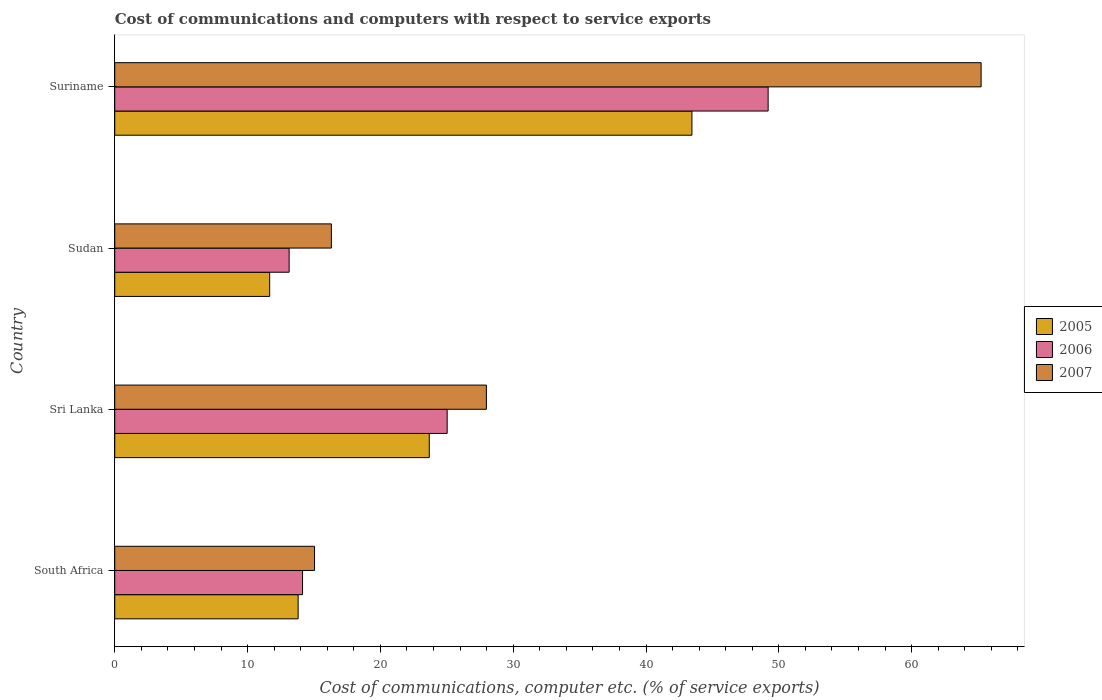How many different coloured bars are there?
Keep it short and to the point. 3. How many groups of bars are there?
Ensure brevity in your answer.  4. Are the number of bars on each tick of the Y-axis equal?
Your response must be concise. Yes. What is the label of the 4th group of bars from the top?
Provide a short and direct response. South Africa. What is the cost of communications and computers in 2006 in Suriname?
Provide a short and direct response. 49.2. Across all countries, what is the maximum cost of communications and computers in 2006?
Ensure brevity in your answer.  49.2. Across all countries, what is the minimum cost of communications and computers in 2007?
Make the answer very short. 15.04. In which country was the cost of communications and computers in 2005 maximum?
Your answer should be compact. Suriname. In which country was the cost of communications and computers in 2006 minimum?
Offer a terse response. Sudan. What is the total cost of communications and computers in 2007 in the graph?
Offer a very short reply. 124.57. What is the difference between the cost of communications and computers in 2005 in South Africa and that in Suriname?
Your answer should be very brief. -29.65. What is the difference between the cost of communications and computers in 2006 in Sudan and the cost of communications and computers in 2007 in South Africa?
Ensure brevity in your answer.  -1.91. What is the average cost of communications and computers in 2006 per country?
Make the answer very short. 25.37. What is the difference between the cost of communications and computers in 2006 and cost of communications and computers in 2005 in South Africa?
Provide a succinct answer. 0.33. What is the ratio of the cost of communications and computers in 2007 in South Africa to that in Suriname?
Offer a very short reply. 0.23. What is the difference between the highest and the second highest cost of communications and computers in 2005?
Provide a short and direct response. 19.78. What is the difference between the highest and the lowest cost of communications and computers in 2006?
Make the answer very short. 36.07. In how many countries, is the cost of communications and computers in 2006 greater than the average cost of communications and computers in 2006 taken over all countries?
Offer a terse response. 1. Is the sum of the cost of communications and computers in 2007 in South Africa and Sri Lanka greater than the maximum cost of communications and computers in 2005 across all countries?
Your answer should be very brief. No. What does the 3rd bar from the top in Sudan represents?
Keep it short and to the point. 2005. What does the 2nd bar from the bottom in Sri Lanka represents?
Your answer should be compact. 2006. Are all the bars in the graph horizontal?
Make the answer very short. Yes. How many countries are there in the graph?
Your answer should be compact. 4. What is the difference between two consecutive major ticks on the X-axis?
Offer a very short reply. 10. Does the graph contain any zero values?
Give a very brief answer. No. Where does the legend appear in the graph?
Ensure brevity in your answer.  Center right. How are the legend labels stacked?
Offer a very short reply. Vertical. What is the title of the graph?
Offer a very short reply. Cost of communications and computers with respect to service exports. Does "1981" appear as one of the legend labels in the graph?
Your answer should be compact. No. What is the label or title of the X-axis?
Your answer should be very brief. Cost of communications, computer etc. (% of service exports). What is the label or title of the Y-axis?
Offer a terse response. Country. What is the Cost of communications, computer etc. (% of service exports) in 2005 in South Africa?
Offer a very short reply. 13.81. What is the Cost of communications, computer etc. (% of service exports) in 2006 in South Africa?
Keep it short and to the point. 14.14. What is the Cost of communications, computer etc. (% of service exports) of 2007 in South Africa?
Give a very brief answer. 15.04. What is the Cost of communications, computer etc. (% of service exports) in 2005 in Sri Lanka?
Give a very brief answer. 23.68. What is the Cost of communications, computer etc. (% of service exports) of 2006 in Sri Lanka?
Provide a short and direct response. 25.03. What is the Cost of communications, computer etc. (% of service exports) of 2007 in Sri Lanka?
Your answer should be compact. 27.98. What is the Cost of communications, computer etc. (% of service exports) in 2005 in Sudan?
Give a very brief answer. 11.66. What is the Cost of communications, computer etc. (% of service exports) of 2006 in Sudan?
Your answer should be compact. 13.13. What is the Cost of communications, computer etc. (% of service exports) of 2007 in Sudan?
Keep it short and to the point. 16.31. What is the Cost of communications, computer etc. (% of service exports) in 2005 in Suriname?
Your answer should be compact. 43.46. What is the Cost of communications, computer etc. (% of service exports) of 2006 in Suriname?
Keep it short and to the point. 49.2. What is the Cost of communications, computer etc. (% of service exports) in 2007 in Suriname?
Your response must be concise. 65.23. Across all countries, what is the maximum Cost of communications, computer etc. (% of service exports) in 2005?
Offer a terse response. 43.46. Across all countries, what is the maximum Cost of communications, computer etc. (% of service exports) of 2006?
Offer a very short reply. 49.2. Across all countries, what is the maximum Cost of communications, computer etc. (% of service exports) in 2007?
Offer a very short reply. 65.23. Across all countries, what is the minimum Cost of communications, computer etc. (% of service exports) in 2005?
Your answer should be very brief. 11.66. Across all countries, what is the minimum Cost of communications, computer etc. (% of service exports) in 2006?
Provide a short and direct response. 13.13. Across all countries, what is the minimum Cost of communications, computer etc. (% of service exports) in 2007?
Make the answer very short. 15.04. What is the total Cost of communications, computer etc. (% of service exports) of 2005 in the graph?
Offer a terse response. 92.61. What is the total Cost of communications, computer etc. (% of service exports) of 2006 in the graph?
Ensure brevity in your answer.  101.5. What is the total Cost of communications, computer etc. (% of service exports) in 2007 in the graph?
Your response must be concise. 124.57. What is the difference between the Cost of communications, computer etc. (% of service exports) in 2005 in South Africa and that in Sri Lanka?
Keep it short and to the point. -9.87. What is the difference between the Cost of communications, computer etc. (% of service exports) of 2006 in South Africa and that in Sri Lanka?
Your response must be concise. -10.89. What is the difference between the Cost of communications, computer etc. (% of service exports) of 2007 in South Africa and that in Sri Lanka?
Ensure brevity in your answer.  -12.94. What is the difference between the Cost of communications, computer etc. (% of service exports) in 2005 in South Africa and that in Sudan?
Keep it short and to the point. 2.14. What is the difference between the Cost of communications, computer etc. (% of service exports) of 2006 in South Africa and that in Sudan?
Make the answer very short. 1.01. What is the difference between the Cost of communications, computer etc. (% of service exports) of 2007 in South Africa and that in Sudan?
Provide a short and direct response. -1.27. What is the difference between the Cost of communications, computer etc. (% of service exports) in 2005 in South Africa and that in Suriname?
Make the answer very short. -29.65. What is the difference between the Cost of communications, computer etc. (% of service exports) of 2006 in South Africa and that in Suriname?
Offer a very short reply. -35.06. What is the difference between the Cost of communications, computer etc. (% of service exports) of 2007 in South Africa and that in Suriname?
Your answer should be compact. -50.19. What is the difference between the Cost of communications, computer etc. (% of service exports) in 2005 in Sri Lanka and that in Sudan?
Make the answer very short. 12.02. What is the difference between the Cost of communications, computer etc. (% of service exports) of 2006 in Sri Lanka and that in Sudan?
Make the answer very short. 11.9. What is the difference between the Cost of communications, computer etc. (% of service exports) of 2007 in Sri Lanka and that in Sudan?
Your response must be concise. 11.67. What is the difference between the Cost of communications, computer etc. (% of service exports) in 2005 in Sri Lanka and that in Suriname?
Give a very brief answer. -19.78. What is the difference between the Cost of communications, computer etc. (% of service exports) in 2006 in Sri Lanka and that in Suriname?
Provide a short and direct response. -24.17. What is the difference between the Cost of communications, computer etc. (% of service exports) of 2007 in Sri Lanka and that in Suriname?
Keep it short and to the point. -37.25. What is the difference between the Cost of communications, computer etc. (% of service exports) in 2005 in Sudan and that in Suriname?
Give a very brief answer. -31.79. What is the difference between the Cost of communications, computer etc. (% of service exports) in 2006 in Sudan and that in Suriname?
Your response must be concise. -36.07. What is the difference between the Cost of communications, computer etc. (% of service exports) of 2007 in Sudan and that in Suriname?
Your response must be concise. -48.92. What is the difference between the Cost of communications, computer etc. (% of service exports) of 2005 in South Africa and the Cost of communications, computer etc. (% of service exports) of 2006 in Sri Lanka?
Offer a terse response. -11.22. What is the difference between the Cost of communications, computer etc. (% of service exports) in 2005 in South Africa and the Cost of communications, computer etc. (% of service exports) in 2007 in Sri Lanka?
Give a very brief answer. -14.17. What is the difference between the Cost of communications, computer etc. (% of service exports) of 2006 in South Africa and the Cost of communications, computer etc. (% of service exports) of 2007 in Sri Lanka?
Make the answer very short. -13.84. What is the difference between the Cost of communications, computer etc. (% of service exports) in 2005 in South Africa and the Cost of communications, computer etc. (% of service exports) in 2006 in Sudan?
Offer a terse response. 0.68. What is the difference between the Cost of communications, computer etc. (% of service exports) of 2005 in South Africa and the Cost of communications, computer etc. (% of service exports) of 2007 in Sudan?
Give a very brief answer. -2.5. What is the difference between the Cost of communications, computer etc. (% of service exports) of 2006 in South Africa and the Cost of communications, computer etc. (% of service exports) of 2007 in Sudan?
Your answer should be compact. -2.17. What is the difference between the Cost of communications, computer etc. (% of service exports) in 2005 in South Africa and the Cost of communications, computer etc. (% of service exports) in 2006 in Suriname?
Your answer should be very brief. -35.39. What is the difference between the Cost of communications, computer etc. (% of service exports) of 2005 in South Africa and the Cost of communications, computer etc. (% of service exports) of 2007 in Suriname?
Provide a succinct answer. -51.42. What is the difference between the Cost of communications, computer etc. (% of service exports) of 2006 in South Africa and the Cost of communications, computer etc. (% of service exports) of 2007 in Suriname?
Your answer should be compact. -51.09. What is the difference between the Cost of communications, computer etc. (% of service exports) in 2005 in Sri Lanka and the Cost of communications, computer etc. (% of service exports) in 2006 in Sudan?
Give a very brief answer. 10.55. What is the difference between the Cost of communications, computer etc. (% of service exports) in 2005 in Sri Lanka and the Cost of communications, computer etc. (% of service exports) in 2007 in Sudan?
Offer a terse response. 7.37. What is the difference between the Cost of communications, computer etc. (% of service exports) in 2006 in Sri Lanka and the Cost of communications, computer etc. (% of service exports) in 2007 in Sudan?
Give a very brief answer. 8.72. What is the difference between the Cost of communications, computer etc. (% of service exports) of 2005 in Sri Lanka and the Cost of communications, computer etc. (% of service exports) of 2006 in Suriname?
Keep it short and to the point. -25.52. What is the difference between the Cost of communications, computer etc. (% of service exports) in 2005 in Sri Lanka and the Cost of communications, computer etc. (% of service exports) in 2007 in Suriname?
Your answer should be very brief. -41.55. What is the difference between the Cost of communications, computer etc. (% of service exports) in 2006 in Sri Lanka and the Cost of communications, computer etc. (% of service exports) in 2007 in Suriname?
Provide a short and direct response. -40.2. What is the difference between the Cost of communications, computer etc. (% of service exports) in 2005 in Sudan and the Cost of communications, computer etc. (% of service exports) in 2006 in Suriname?
Give a very brief answer. -37.53. What is the difference between the Cost of communications, computer etc. (% of service exports) in 2005 in Sudan and the Cost of communications, computer etc. (% of service exports) in 2007 in Suriname?
Provide a succinct answer. -53.57. What is the difference between the Cost of communications, computer etc. (% of service exports) in 2006 in Sudan and the Cost of communications, computer etc. (% of service exports) in 2007 in Suriname?
Offer a very short reply. -52.1. What is the average Cost of communications, computer etc. (% of service exports) in 2005 per country?
Your answer should be very brief. 23.15. What is the average Cost of communications, computer etc. (% of service exports) of 2006 per country?
Your response must be concise. 25.37. What is the average Cost of communications, computer etc. (% of service exports) in 2007 per country?
Give a very brief answer. 31.14. What is the difference between the Cost of communications, computer etc. (% of service exports) of 2005 and Cost of communications, computer etc. (% of service exports) of 2006 in South Africa?
Provide a short and direct response. -0.33. What is the difference between the Cost of communications, computer etc. (% of service exports) in 2005 and Cost of communications, computer etc. (% of service exports) in 2007 in South Africa?
Make the answer very short. -1.23. What is the difference between the Cost of communications, computer etc. (% of service exports) in 2006 and Cost of communications, computer etc. (% of service exports) in 2007 in South Africa?
Your answer should be very brief. -0.9. What is the difference between the Cost of communications, computer etc. (% of service exports) in 2005 and Cost of communications, computer etc. (% of service exports) in 2006 in Sri Lanka?
Keep it short and to the point. -1.35. What is the difference between the Cost of communications, computer etc. (% of service exports) in 2005 and Cost of communications, computer etc. (% of service exports) in 2007 in Sri Lanka?
Make the answer very short. -4.3. What is the difference between the Cost of communications, computer etc. (% of service exports) of 2006 and Cost of communications, computer etc. (% of service exports) of 2007 in Sri Lanka?
Keep it short and to the point. -2.95. What is the difference between the Cost of communications, computer etc. (% of service exports) of 2005 and Cost of communications, computer etc. (% of service exports) of 2006 in Sudan?
Ensure brevity in your answer.  -1.47. What is the difference between the Cost of communications, computer etc. (% of service exports) in 2005 and Cost of communications, computer etc. (% of service exports) in 2007 in Sudan?
Your response must be concise. -4.65. What is the difference between the Cost of communications, computer etc. (% of service exports) in 2006 and Cost of communications, computer etc. (% of service exports) in 2007 in Sudan?
Your answer should be compact. -3.18. What is the difference between the Cost of communications, computer etc. (% of service exports) of 2005 and Cost of communications, computer etc. (% of service exports) of 2006 in Suriname?
Keep it short and to the point. -5.74. What is the difference between the Cost of communications, computer etc. (% of service exports) of 2005 and Cost of communications, computer etc. (% of service exports) of 2007 in Suriname?
Your answer should be compact. -21.77. What is the difference between the Cost of communications, computer etc. (% of service exports) in 2006 and Cost of communications, computer etc. (% of service exports) in 2007 in Suriname?
Your response must be concise. -16.04. What is the ratio of the Cost of communications, computer etc. (% of service exports) of 2005 in South Africa to that in Sri Lanka?
Give a very brief answer. 0.58. What is the ratio of the Cost of communications, computer etc. (% of service exports) of 2006 in South Africa to that in Sri Lanka?
Provide a short and direct response. 0.56. What is the ratio of the Cost of communications, computer etc. (% of service exports) of 2007 in South Africa to that in Sri Lanka?
Offer a terse response. 0.54. What is the ratio of the Cost of communications, computer etc. (% of service exports) of 2005 in South Africa to that in Sudan?
Provide a short and direct response. 1.18. What is the ratio of the Cost of communications, computer etc. (% of service exports) in 2007 in South Africa to that in Sudan?
Your answer should be compact. 0.92. What is the ratio of the Cost of communications, computer etc. (% of service exports) of 2005 in South Africa to that in Suriname?
Provide a succinct answer. 0.32. What is the ratio of the Cost of communications, computer etc. (% of service exports) of 2006 in South Africa to that in Suriname?
Your answer should be compact. 0.29. What is the ratio of the Cost of communications, computer etc. (% of service exports) in 2007 in South Africa to that in Suriname?
Provide a short and direct response. 0.23. What is the ratio of the Cost of communications, computer etc. (% of service exports) in 2005 in Sri Lanka to that in Sudan?
Provide a succinct answer. 2.03. What is the ratio of the Cost of communications, computer etc. (% of service exports) of 2006 in Sri Lanka to that in Sudan?
Ensure brevity in your answer.  1.91. What is the ratio of the Cost of communications, computer etc. (% of service exports) in 2007 in Sri Lanka to that in Sudan?
Make the answer very short. 1.72. What is the ratio of the Cost of communications, computer etc. (% of service exports) of 2005 in Sri Lanka to that in Suriname?
Your answer should be very brief. 0.54. What is the ratio of the Cost of communications, computer etc. (% of service exports) of 2006 in Sri Lanka to that in Suriname?
Give a very brief answer. 0.51. What is the ratio of the Cost of communications, computer etc. (% of service exports) in 2007 in Sri Lanka to that in Suriname?
Offer a terse response. 0.43. What is the ratio of the Cost of communications, computer etc. (% of service exports) of 2005 in Sudan to that in Suriname?
Ensure brevity in your answer.  0.27. What is the ratio of the Cost of communications, computer etc. (% of service exports) in 2006 in Sudan to that in Suriname?
Your response must be concise. 0.27. What is the ratio of the Cost of communications, computer etc. (% of service exports) of 2007 in Sudan to that in Suriname?
Make the answer very short. 0.25. What is the difference between the highest and the second highest Cost of communications, computer etc. (% of service exports) of 2005?
Ensure brevity in your answer.  19.78. What is the difference between the highest and the second highest Cost of communications, computer etc. (% of service exports) of 2006?
Keep it short and to the point. 24.17. What is the difference between the highest and the second highest Cost of communications, computer etc. (% of service exports) of 2007?
Provide a short and direct response. 37.25. What is the difference between the highest and the lowest Cost of communications, computer etc. (% of service exports) of 2005?
Your response must be concise. 31.79. What is the difference between the highest and the lowest Cost of communications, computer etc. (% of service exports) in 2006?
Give a very brief answer. 36.07. What is the difference between the highest and the lowest Cost of communications, computer etc. (% of service exports) of 2007?
Keep it short and to the point. 50.19. 